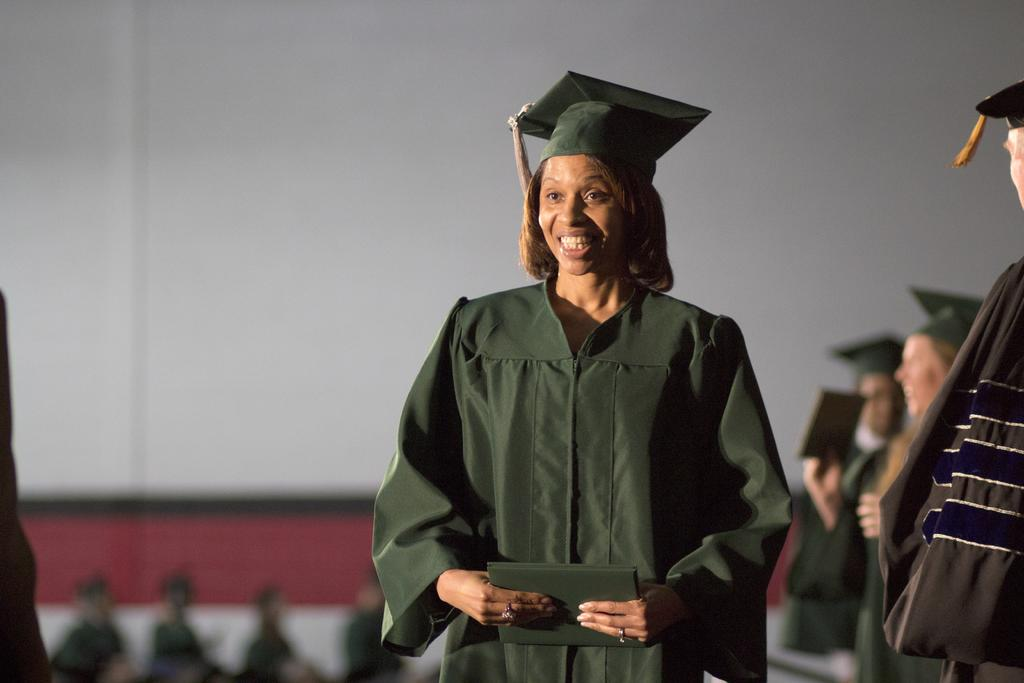What is the person in the image doing? The person is standing and holding an object. Can you describe the group of people in the image? There is a group of people standing towards the right of the image. What is the color of the background behind the person? The background behind the person is white. What type of butter is being used by the person's grandmother in the image? There is no grandmother or butter present in the image. What is inside the sack that the person is holding in the image? The image does not show the contents of the object the person is holding, so it cannot be determined what is inside the sack. 